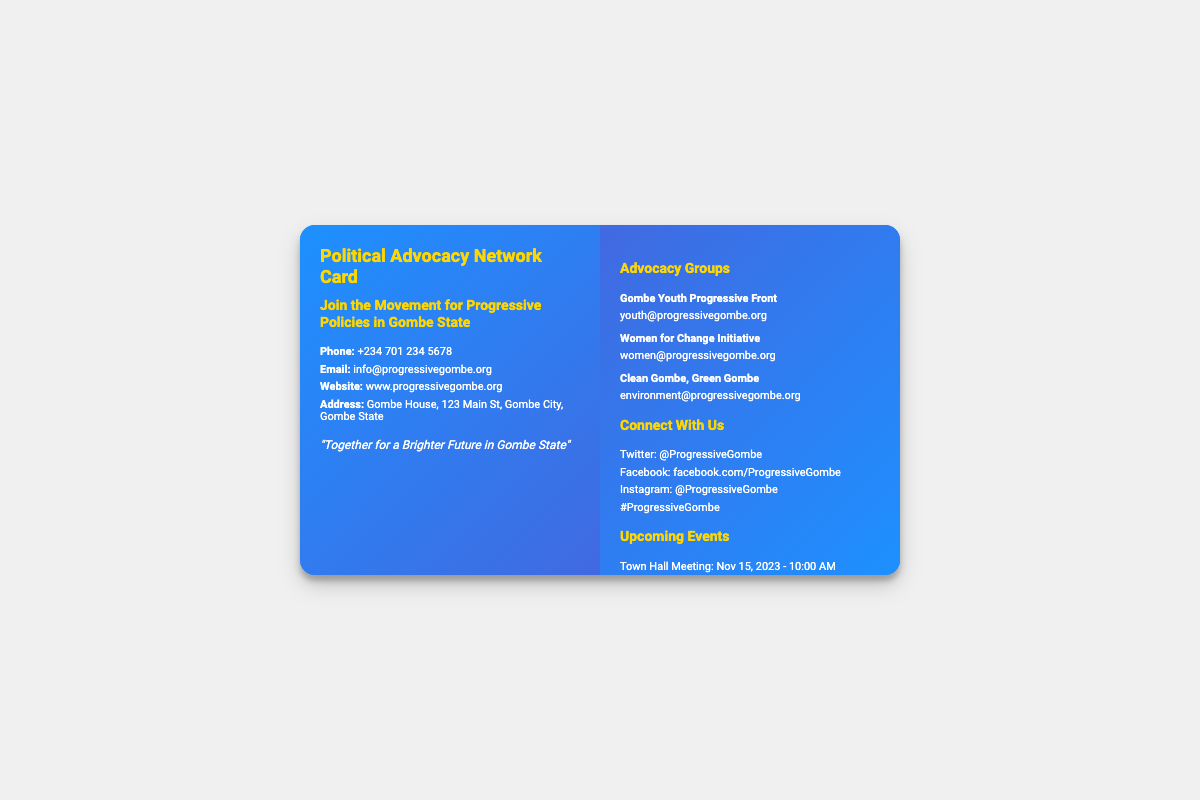What is the phone number listed? The phone number provided in the document is shown clearly for contact purposes.
Answer: +234 701 234 5678 What is the website URL? The website URL is a key point of contact for more information, located in the document.
Answer: www.progressivegombe.org What is the event scheduled for Dec 1, 2023? The document outlines upcoming events, specifically noting the date and title for community engagement.
Answer: Community Clean-Up Drive How many advocacy groups are listed? The total number of advocacy groups mentioned contributes to understanding the network's outreach and focus areas.
Answer: 3 What is the motto on the front of the card? The motto encapsulates the mission of the network and is important for conveying their vision.
Answer: "Together for a Brighter Future in Gombe State" Which social media platform is associated with the handle @ProgressiveGombe? The social media platforms listed provide avenues for connection with the advocacy network, and the handle is critical for outreach.
Answer: Twitter What time does the Town Hall Meeting start? The time for the event is part of the specific information listed under upcoming events to ensure attendance.
Answer: 10:00 AM What is the focus of the "Clean Gombe, Green Gombe" advocacy group? The name of the advocacy group suggests its focus, indicating the areas of interest for the network's initiatives.
Answer: Environment What type of event is scheduled for Dec 7, 2023? The type of event provides insight into the activities planned by the advocacy network for community involvement.
Answer: Policy Workshop 